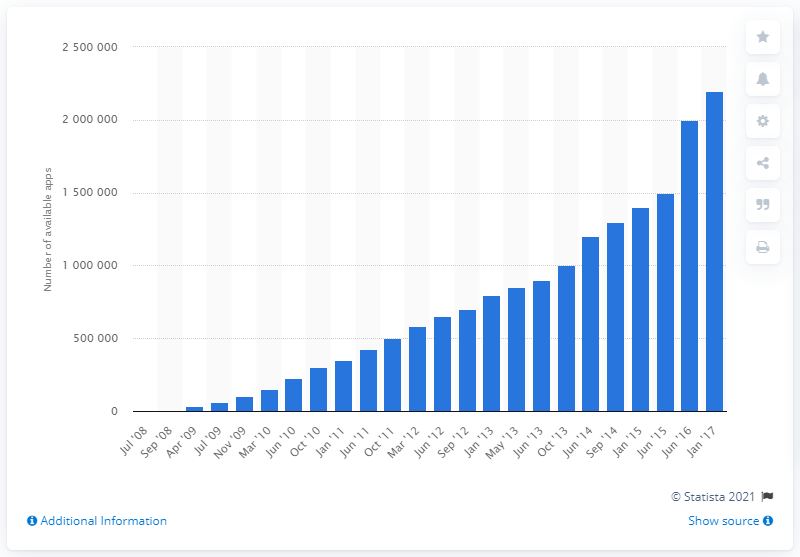Indicate a few pertinent items in this graphic. As of January 2017, there were approximately 2.2 million mobile apps available to download for various iOS devices. 